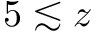Convert formula to latex. <formula><loc_0><loc_0><loc_500><loc_500>5 \lesssim z</formula> 